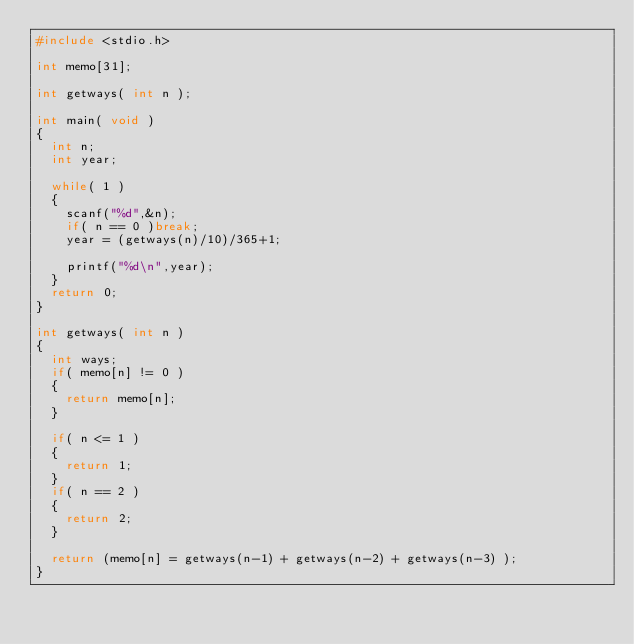Convert code to text. <code><loc_0><loc_0><loc_500><loc_500><_C_>#include <stdio.h>

int memo[31];

int getways( int n );

int main( void )
{
	int n;
	int year;
	
	while( 1 )
	{
		scanf("%d",&n);
		if( n == 0 )break;
		year = (getways(n)/10)/365+1;
		
		printf("%d\n",year);
	}
	return 0;
}

int getways( int n )
{
	int ways;
	if( memo[n] != 0 )
	{
		return memo[n];
	}
	
	if( n <= 1 )
	{
		return 1;
	}
	if( n == 2 )
	{
		return 2;
	}
	
	return (memo[n] = getways(n-1) + getways(n-2) + getways(n-3) );
}</code> 